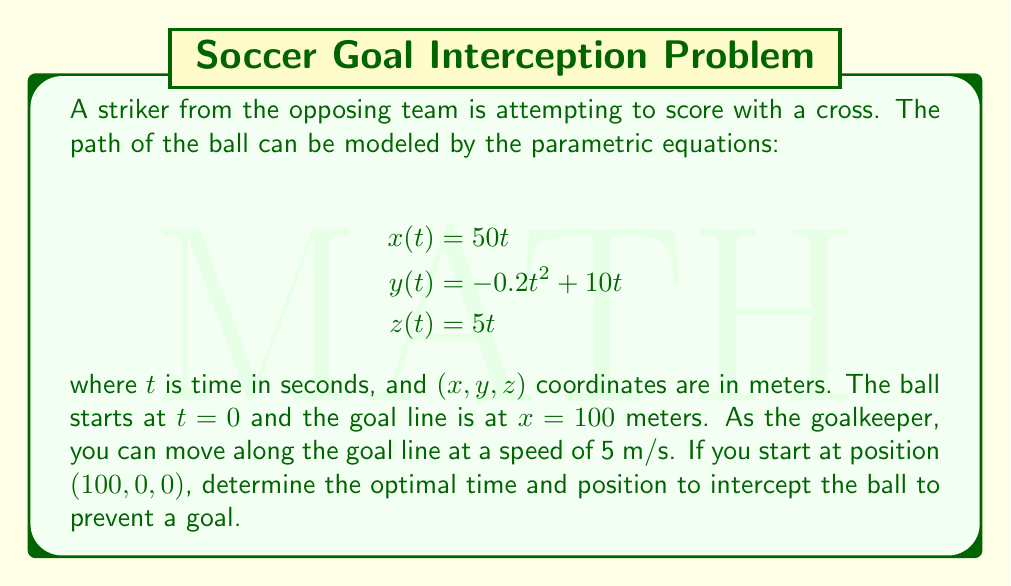Solve this math problem. To solve this problem, we need to follow these steps:

1) First, we need to find when the ball reaches the goal line. This occurs when $x = 100$:

   $100 = 50t$
   $t = 2$ seconds

2) At $t = 2$, we can find the $y$ and $z$ coordinates of the ball:

   $y(2) = -0.2(2)^2 + 10(2) = -0.8 + 20 = 19.2$ meters
   $z(2) = 5(2) = 10$ meters

3) The ball will cross the goal line at point $(100, 19.2, 10)$.

4) Now, we need to determine if the goalkeeper can reach this point in time. The goalkeeper starts at $(100, 0, 0)$ and can move along the goal line at 5 m/s.

5) The distance the goalkeeper needs to travel is:

   $\sqrt{19.2^2 + 10^2} = \sqrt{368.64 + 100} = \sqrt{468.64} \approx 21.65$ meters

6) The time it takes the goalkeeper to reach this point is:

   $21.65 / 5 = 4.33$ seconds

7) Since this is more than the 2 seconds it takes the ball to reach the goal line, the goalkeeper cannot reach the exact crossing point in time.

8) The optimal interception point will be the farthest point the goalkeeper can reach in 2 seconds:

   Distance traveled in 2 seconds = $5 * 2 = 10$ meters

9) The optimal interception point will be 10 meters up from the starting position:

   $(100, 10\sin\theta, 10\cos\theta)$

   where $\theta = \tan^{-1}(19.2/10) \approx 62.4°$

Therefore, the optimal interception point is approximately $(100, 8.87, 4.63)$.
Answer: The optimal time to intercept the ball is 2 seconds, and the optimal position is approximately $(100, 8.87, 4.63)$ meters. 